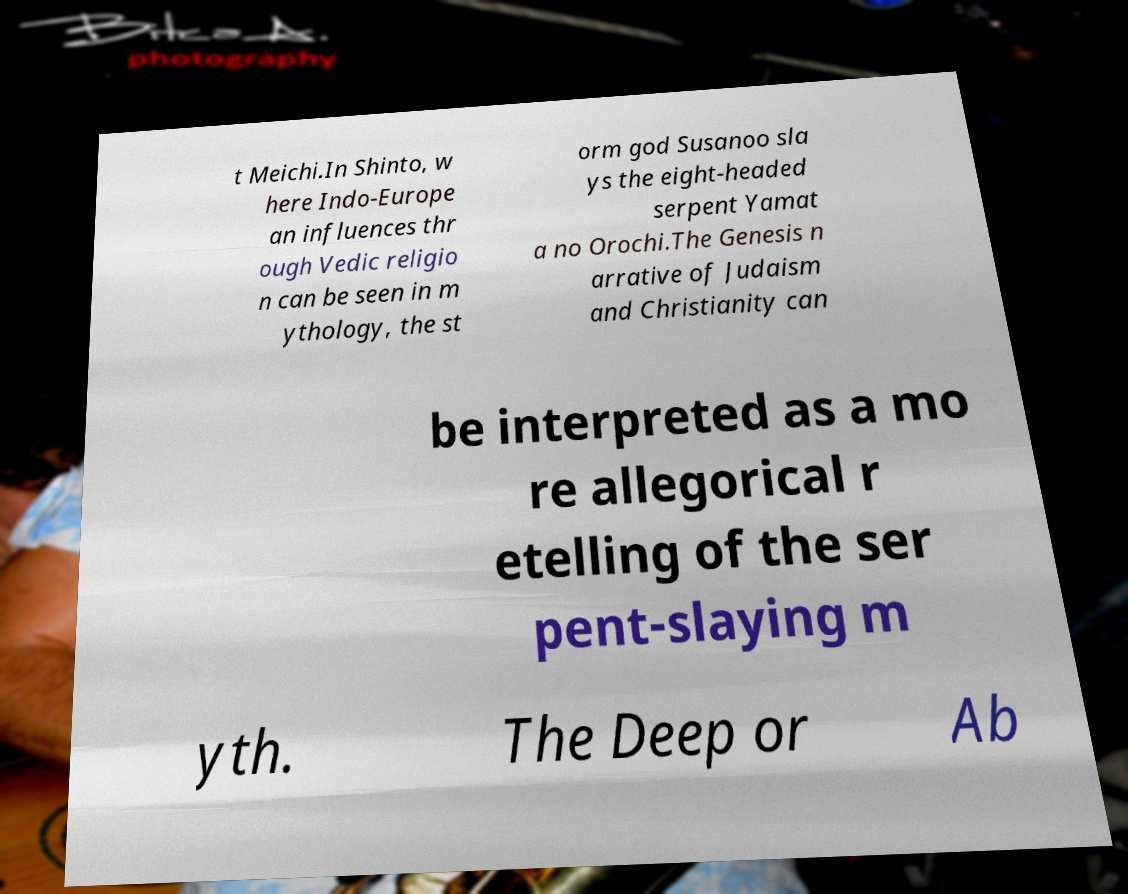Please identify and transcribe the text found in this image. t Meichi.In Shinto, w here Indo-Europe an influences thr ough Vedic religio n can be seen in m ythology, the st orm god Susanoo sla ys the eight-headed serpent Yamat a no Orochi.The Genesis n arrative of Judaism and Christianity can be interpreted as a mo re allegorical r etelling of the ser pent-slaying m yth. The Deep or Ab 